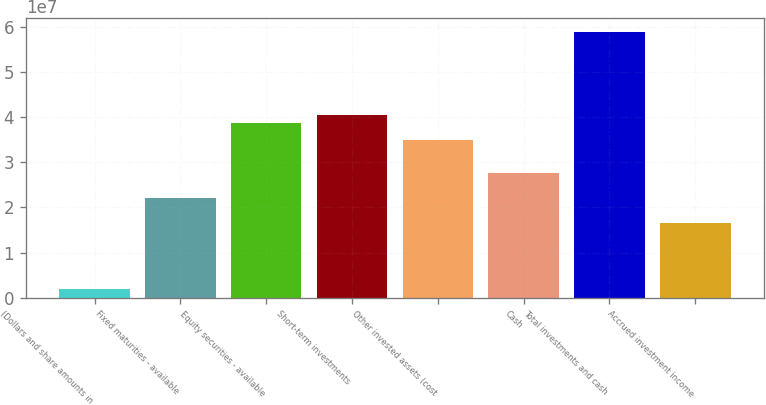Convert chart to OTSL. <chart><loc_0><loc_0><loc_500><loc_500><bar_chart><fcel>(Dollars and share amounts in<fcel>Fixed maturities - available<fcel>Equity securities - available<fcel>Short-term investments<fcel>Other invested assets (cost<fcel>Cash<fcel>Total investments and cash<fcel>Accrued investment income<nl><fcel>1.84139e+06<fcel>2.20894e+07<fcel>3.8656e+07<fcel>4.04967e+07<fcel>3.49746e+07<fcel>2.76116e+07<fcel>5.89041e+07<fcel>1.65672e+07<nl></chart> 